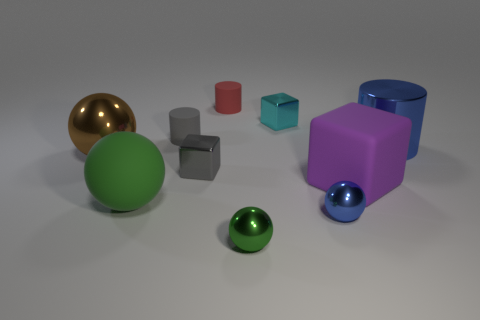Are there any tiny metallic objects of the same color as the rubber ball?
Keep it short and to the point. Yes. Are there any large objects of the same shape as the small cyan metal thing?
Offer a very short reply. Yes. What is the shape of the rubber object that is left of the cyan thing and in front of the gray rubber thing?
Offer a terse response. Sphere. What number of big balls are the same material as the small cyan cube?
Offer a terse response. 1. Are there fewer large blue objects in front of the big purple matte cube than big yellow matte things?
Offer a very short reply. No. There is a cylinder that is right of the small blue ball; are there any large metallic objects left of it?
Ensure brevity in your answer.  Yes. Is the purple thing the same size as the gray rubber thing?
Make the answer very short. No. The gray thing behind the small shiny block in front of the large shiny object on the right side of the tiny red thing is made of what material?
Provide a short and direct response. Rubber. Is the number of rubber cylinders that are on the right side of the big metallic ball the same as the number of tiny metal blocks?
Ensure brevity in your answer.  Yes. What number of objects are gray shiny cubes or tiny metallic balls?
Your answer should be compact. 3. 